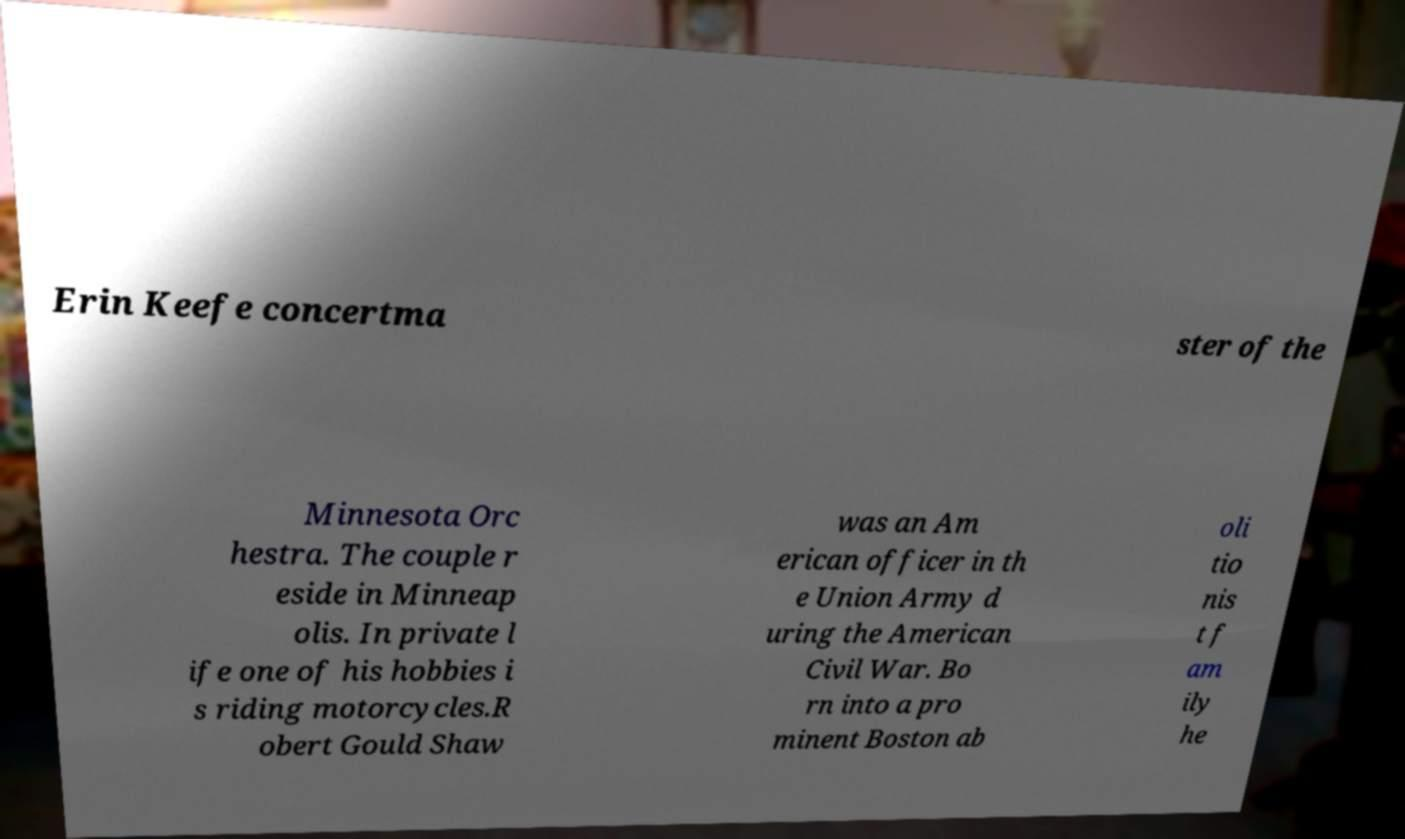What messages or text are displayed in this image? I need them in a readable, typed format. Erin Keefe concertma ster of the Minnesota Orc hestra. The couple r eside in Minneap olis. In private l ife one of his hobbies i s riding motorcycles.R obert Gould Shaw was an Am erican officer in th e Union Army d uring the American Civil War. Bo rn into a pro minent Boston ab oli tio nis t f am ily he 